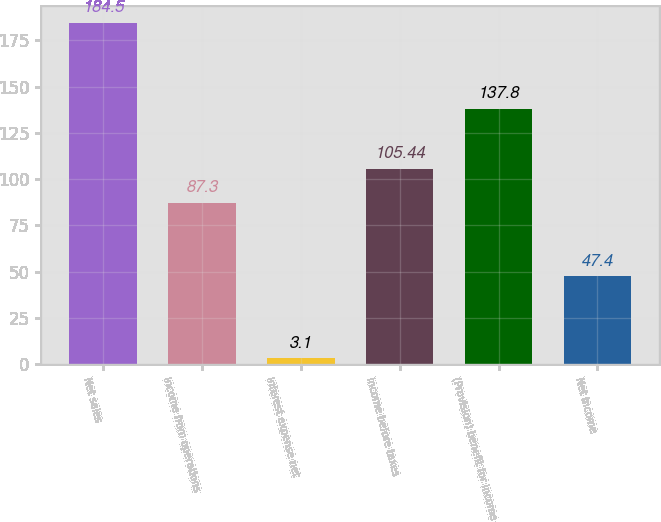<chart> <loc_0><loc_0><loc_500><loc_500><bar_chart><fcel>Net sales<fcel>Income from operations<fcel>Interest expense net<fcel>Income before taxes<fcel>(Provision) benefit for income<fcel>Net income<nl><fcel>184.5<fcel>87.3<fcel>3.1<fcel>105.44<fcel>137.8<fcel>47.4<nl></chart> 